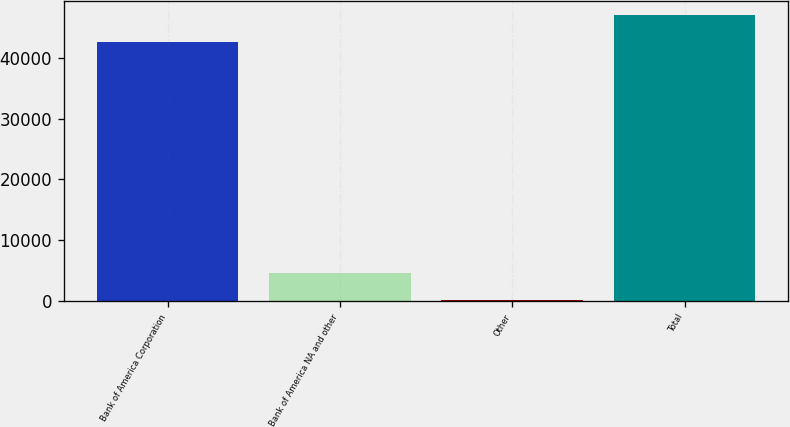<chart> <loc_0><loc_0><loc_500><loc_500><bar_chart><fcel>Bank of America Corporation<fcel>Bank of America NA and other<fcel>Other<fcel>Total<nl><fcel>42526<fcel>4683.2<fcel>214<fcel>46995.2<nl></chart> 